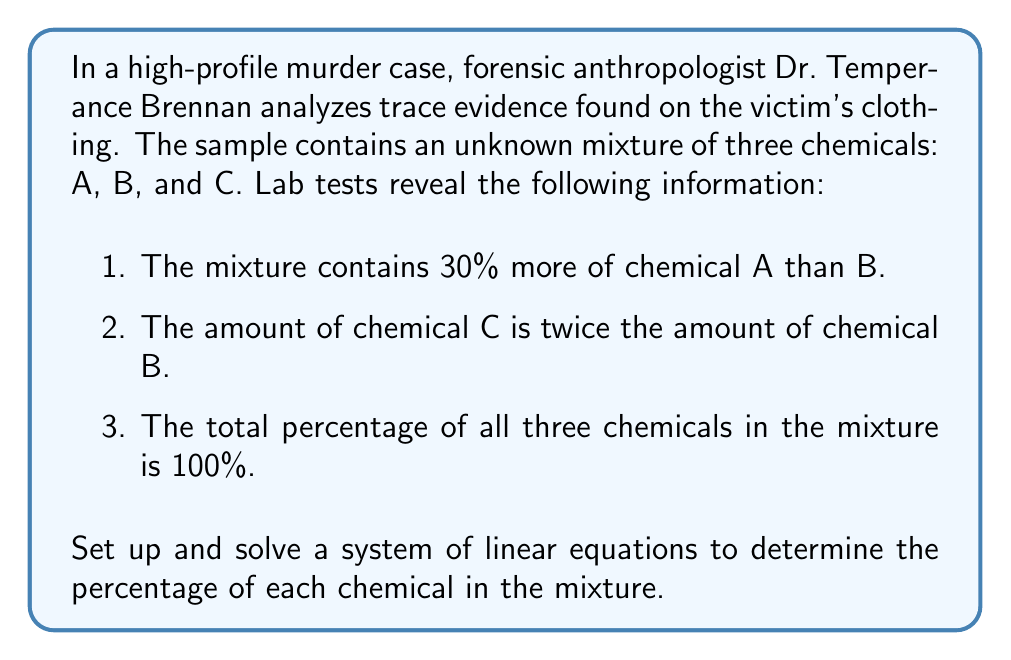Can you solve this math problem? Let's approach this problem step-by-step, just as Dr. Brennan would in her lab:

1. Define variables:
   Let $x$ = percentage of chemical A
   Let $y$ = percentage of chemical B
   Let $z$ = percentage of chemical C

2. Set up the system of linear equations based on the given information:

   Equation 1: $x = y + 30$ (A is 30% more than B)
   Equation 2: $z = 2y$ (C is twice the amount of B)
   Equation 3: $x + y + z = 100$ (Total percentage is 100%)

3. Substitute the expressions for $x$ and $z$ into Equation 3:

   $(y + 30) + y + 2y = 100$

4. Simplify:

   $4y + 30 = 100$

5. Solve for $y$:

   $4y = 70$
   $y = 17.5$

6. Calculate $x$ and $z$:

   $x = y + 30 = 17.5 + 30 = 47.5$
   $z = 2y = 2(17.5) = 35$

7. Verify the solution:

   $x + y + z = 47.5 + 17.5 + 35 = 100$

Therefore, the mixture contains:
- 47.5% of chemical A
- 17.5% of chemical B
- 35% of chemical C
Answer: The trace evidence mixture contains:
$$ \begin{align*}
\text{Chemical A:} & \, 47.5\% \\
\text{Chemical B:} & \, 17.5\% \\
\text{Chemical C:} & \, 35\%
\end{align*} $$ 